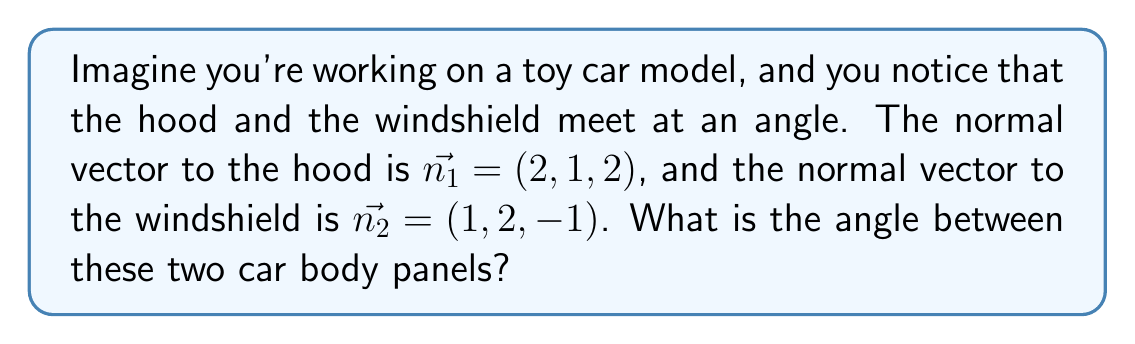Give your solution to this math problem. Let's approach this step-by-step:

1) The angle between two planes is the same as the angle between their normal vectors. We can find this using the dot product formula:

   $$\cos \theta = \frac{\vec{n_1} \cdot \vec{n_2}}{|\vec{n_1}||\vec{n_2}|}$$

2) First, let's calculate the dot product $\vec{n_1} \cdot \vec{n_2}$:
   $$\vec{n_1} \cdot \vec{n_2} = (2)(1) + (1)(2) + (2)(-1) = 2 + 2 - 2 = 2$$

3) Now, we need to calculate the magnitudes of the vectors:
   $$|\vec{n_1}| = \sqrt{2^2 + 1^2 + 2^2} = \sqrt{9} = 3$$
   $$|\vec{n_2}| = \sqrt{1^2 + 2^2 + (-1)^2} = \sqrt{6}$$

4) Substituting these into our formula:
   $$\cos \theta = \frac{2}{3\sqrt{6}}$$

5) To find $\theta$, we need to take the inverse cosine (arccos) of both sides:
   $$\theta = \arccos(\frac{2}{3\sqrt{6}})$$

6) Using a calculator or computer, we can evaluate this:
   $$\theta \approx 1.3181 \text{ radians}$$

7) Converting to degrees:
   $$\theta \approx 75.52°$$
Answer: $75.52°$ 